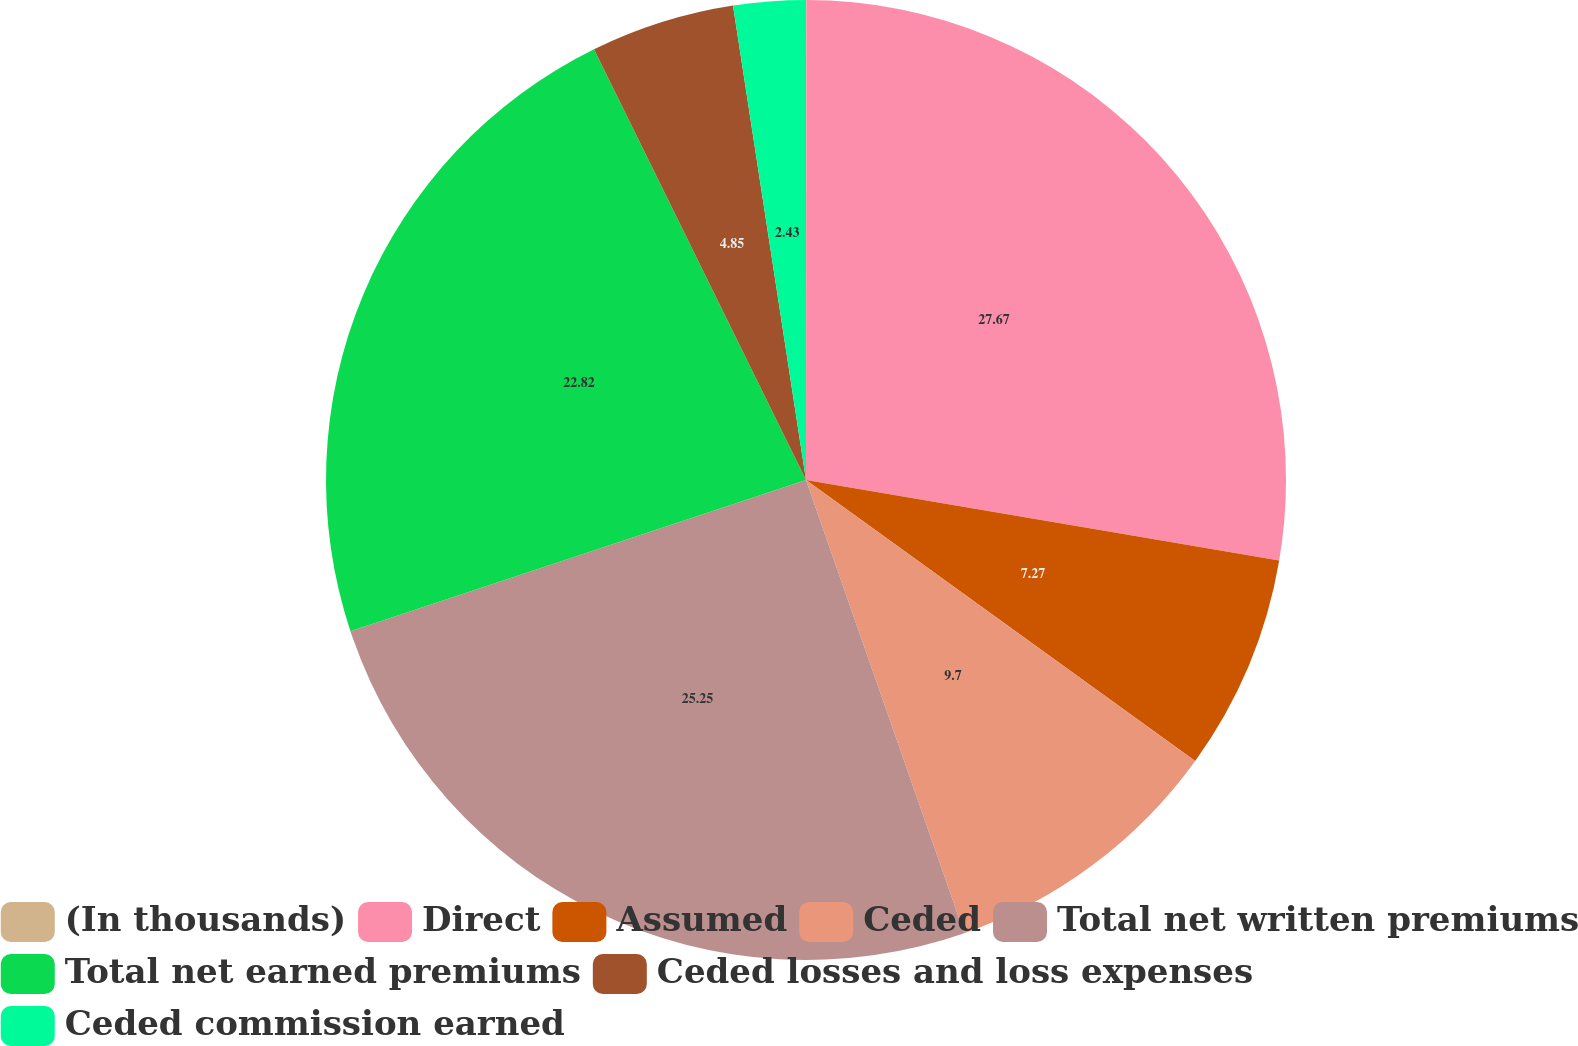Convert chart. <chart><loc_0><loc_0><loc_500><loc_500><pie_chart><fcel>(In thousands)<fcel>Direct<fcel>Assumed<fcel>Ceded<fcel>Total net written premiums<fcel>Total net earned premiums<fcel>Ceded losses and loss expenses<fcel>Ceded commission earned<nl><fcel>0.01%<fcel>27.67%<fcel>7.27%<fcel>9.7%<fcel>25.25%<fcel>22.82%<fcel>4.85%<fcel>2.43%<nl></chart> 